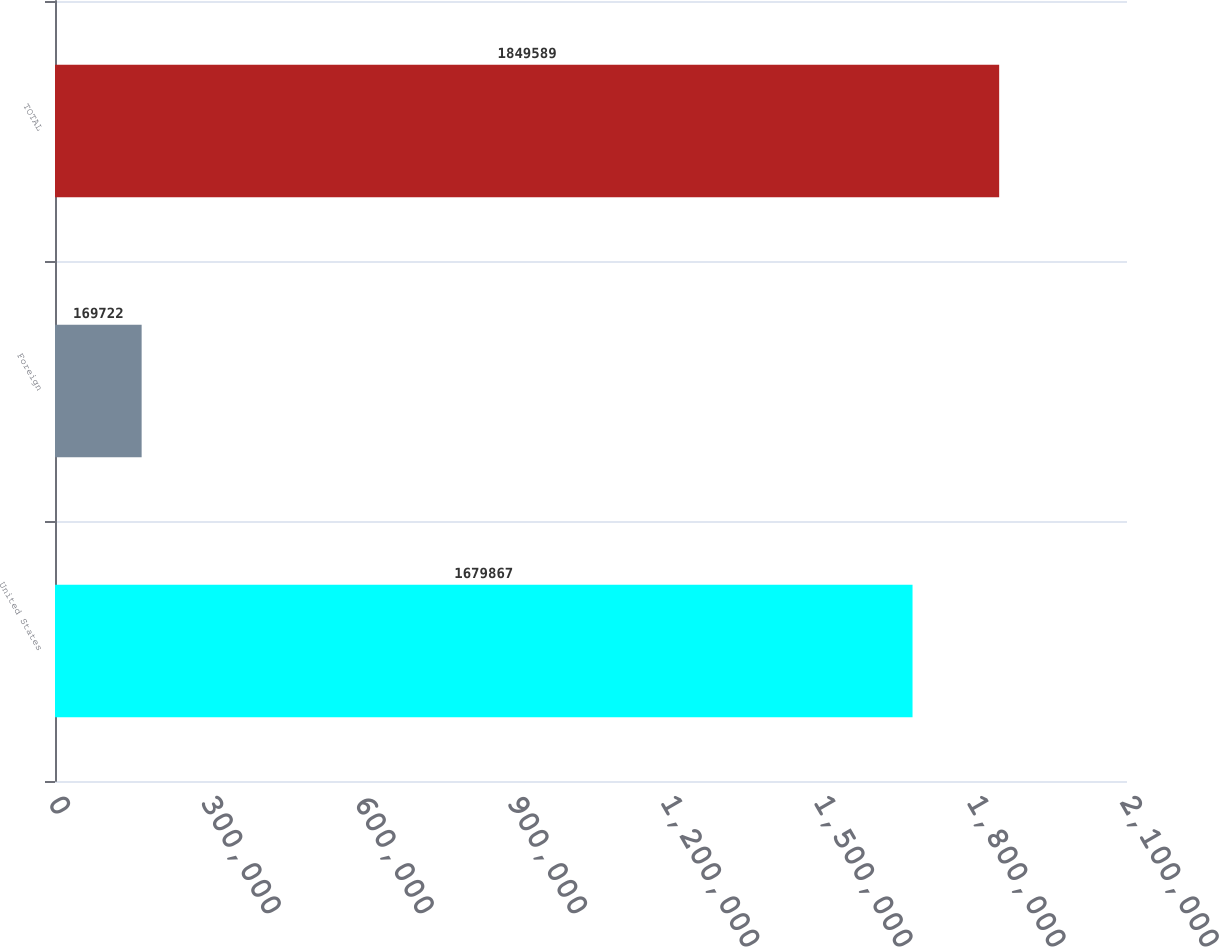Convert chart. <chart><loc_0><loc_0><loc_500><loc_500><bar_chart><fcel>United States<fcel>Foreign<fcel>TOTAL<nl><fcel>1.67987e+06<fcel>169722<fcel>1.84959e+06<nl></chart> 